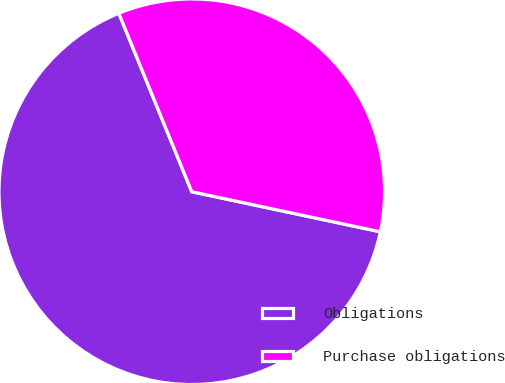Convert chart. <chart><loc_0><loc_0><loc_500><loc_500><pie_chart><fcel>Obligations<fcel>Purchase obligations<nl><fcel>65.49%<fcel>34.51%<nl></chart> 